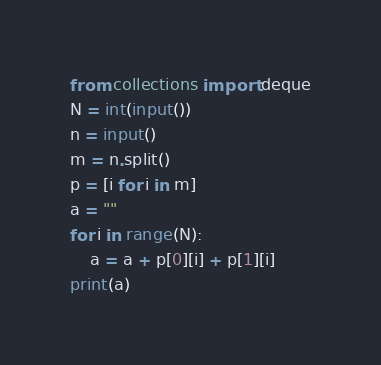Convert code to text. <code><loc_0><loc_0><loc_500><loc_500><_Python_>from collections import deque
N = int(input())
n = input()    
m = n.split()
p = [i for i in m]
a = ""
for i in range(N):
    a = a + p[0][i] + p[1][i]
print(a)</code> 